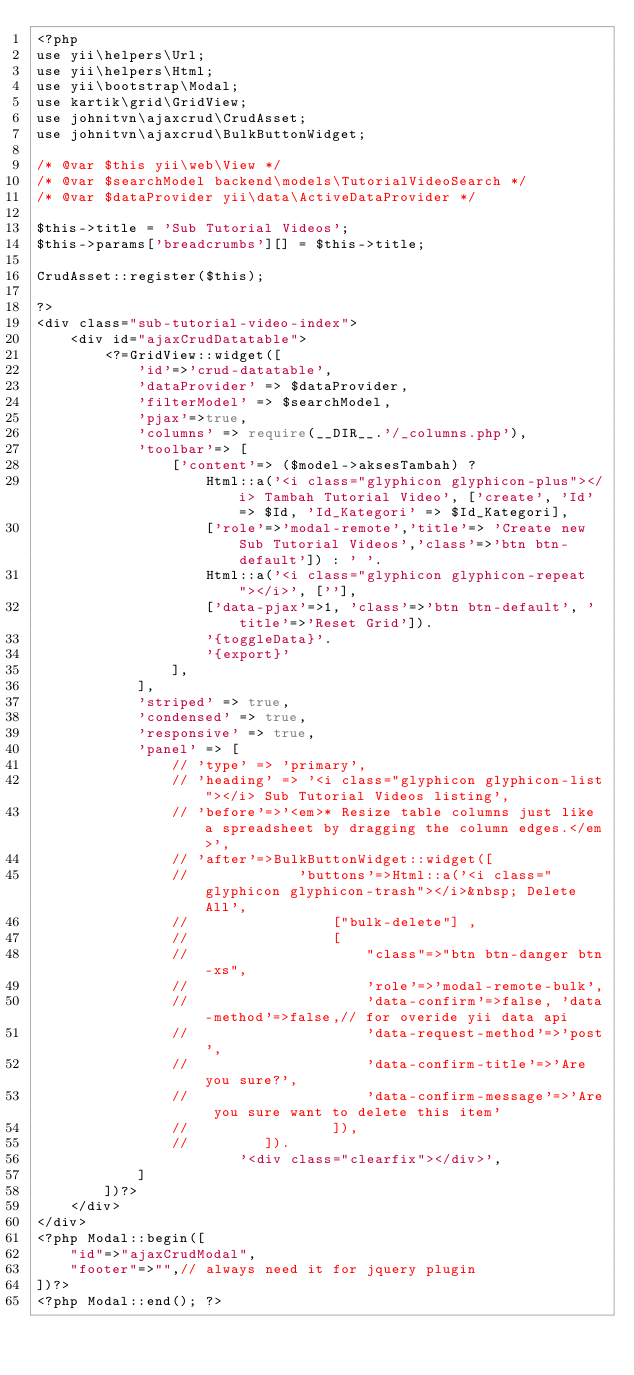<code> <loc_0><loc_0><loc_500><loc_500><_PHP_><?php
use yii\helpers\Url;
use yii\helpers\Html;
use yii\bootstrap\Modal;
use kartik\grid\GridView;
use johnitvn\ajaxcrud\CrudAsset; 
use johnitvn\ajaxcrud\BulkButtonWidget;

/* @var $this yii\web\View */
/* @var $searchModel backend\models\TutorialVideoSearch */
/* @var $dataProvider yii\data\ActiveDataProvider */

$this->title = 'Sub Tutorial Videos';
$this->params['breadcrumbs'][] = $this->title;

CrudAsset::register($this);

?>
<div class="sub-tutorial-video-index">
    <div id="ajaxCrudDatatable">
        <?=GridView::widget([
            'id'=>'crud-datatable',
            'dataProvider' => $dataProvider,
            'filterModel' => $searchModel,
            'pjax'=>true,
            'columns' => require(__DIR__.'/_columns.php'),
            'toolbar'=> [
                ['content'=> ($model->aksesTambah) ?
                    Html::a('<i class="glyphicon glyphicon-plus"></i> Tambah Tutorial Video', ['create', 'Id' => $Id, 'Id_Kategori' => $Id_Kategori],
                    ['role'=>'modal-remote','title'=> 'Create new Sub Tutorial Videos','class'=>'btn btn-default']) : ' '.
                    Html::a('<i class="glyphicon glyphicon-repeat"></i>', [''],
                    ['data-pjax'=>1, 'class'=>'btn btn-default', 'title'=>'Reset Grid']).
                    '{toggleData}'.
                    '{export}'
                ],
            ],          
            'striped' => true,
            'condensed' => true,
            'responsive' => true,          
            'panel' => [
                // 'type' => 'primary', 
                // 'heading' => '<i class="glyphicon glyphicon-list"></i> Sub Tutorial Videos listing',
                // 'before'=>'<em>* Resize table columns just like a spreadsheet by dragging the column edges.</em>',
                // 'after'=>BulkButtonWidget::widget([
                //             'buttons'=>Html::a('<i class="glyphicon glyphicon-trash"></i>&nbsp; Delete All',
                //                 ["bulk-delete"] ,
                //                 [
                //                     "class"=>"btn btn-danger btn-xs",
                //                     'role'=>'modal-remote-bulk',
                //                     'data-confirm'=>false, 'data-method'=>false,// for overide yii data api
                //                     'data-request-method'=>'post',
                //                     'data-confirm-title'=>'Are you sure?',
                //                     'data-confirm-message'=>'Are you sure want to delete this item'
                //                 ]),
                //         ]).                        
                        '<div class="clearfix"></div>',
            ]
        ])?>
    </div>
</div>
<?php Modal::begin([
    "id"=>"ajaxCrudModal",
    "footer"=>"",// always need it for jquery plugin
])?>
<?php Modal::end(); ?>
</code> 